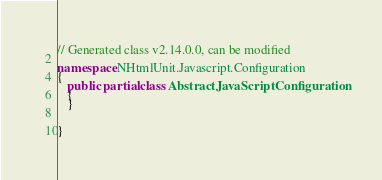Convert code to text. <code><loc_0><loc_0><loc_500><loc_500><_C#_>// Generated class v2.14.0.0, can be modified

namespace NHtmlUnit.Javascript.Configuration
{
   public partial class AbstractJavaScriptConfiguration
   {
   }


}
</code> 